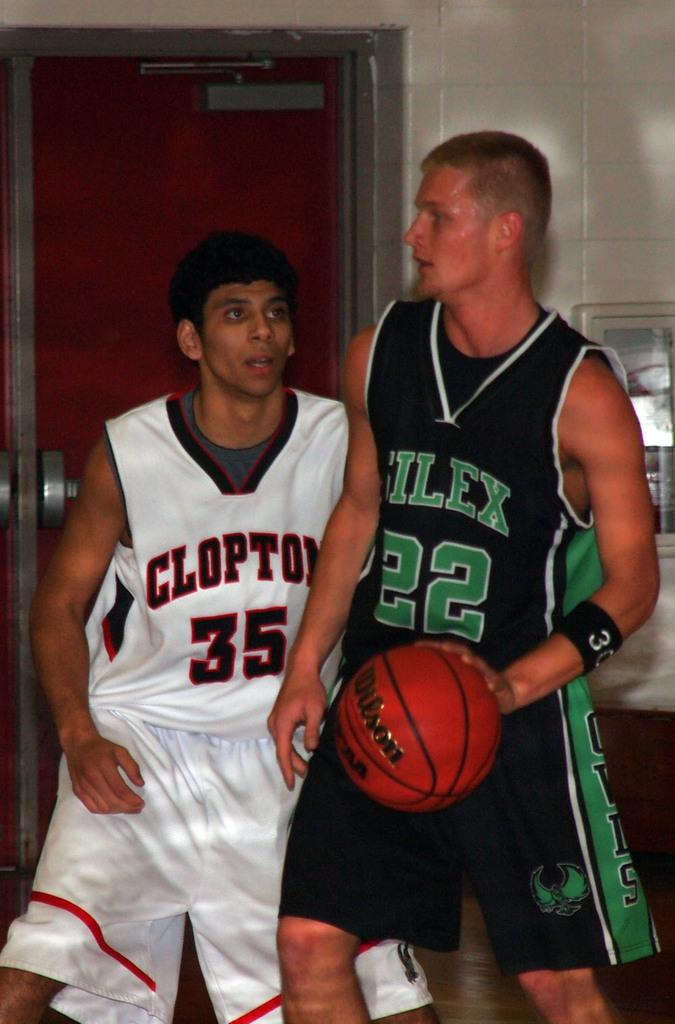Provide a one-sentence caption for the provided image. Player 35 is on the team playing against the player 22. 